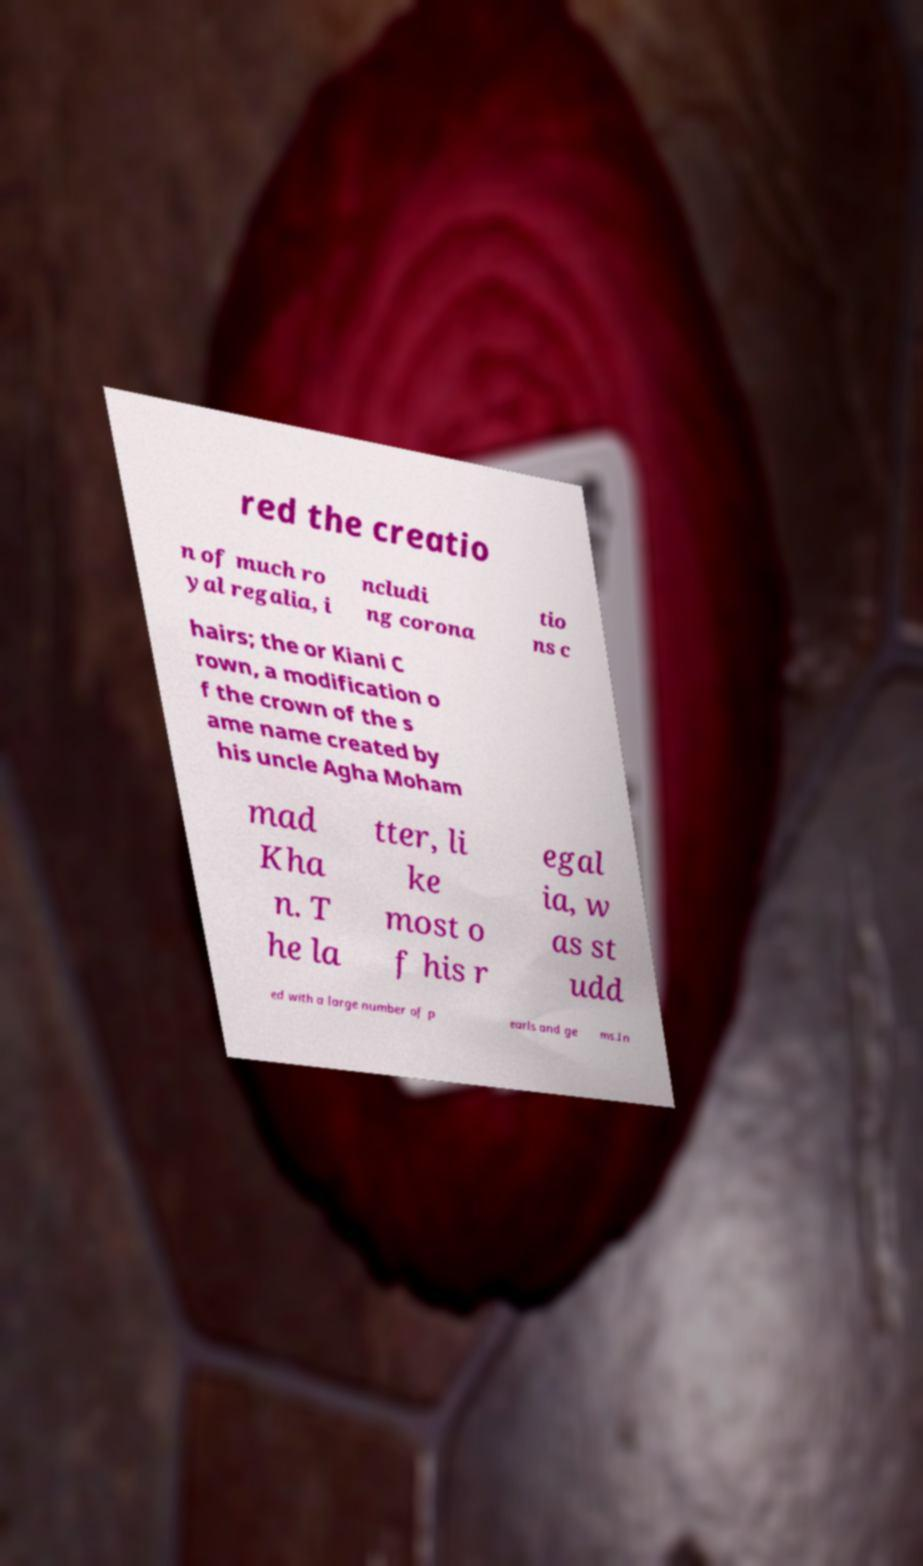Could you assist in decoding the text presented in this image and type it out clearly? red the creatio n of much ro yal regalia, i ncludi ng corona tio ns c hairs; the or Kiani C rown, a modification o f the crown of the s ame name created by his uncle Agha Moham mad Kha n. T he la tter, li ke most o f his r egal ia, w as st udd ed with a large number of p earls and ge ms.In 